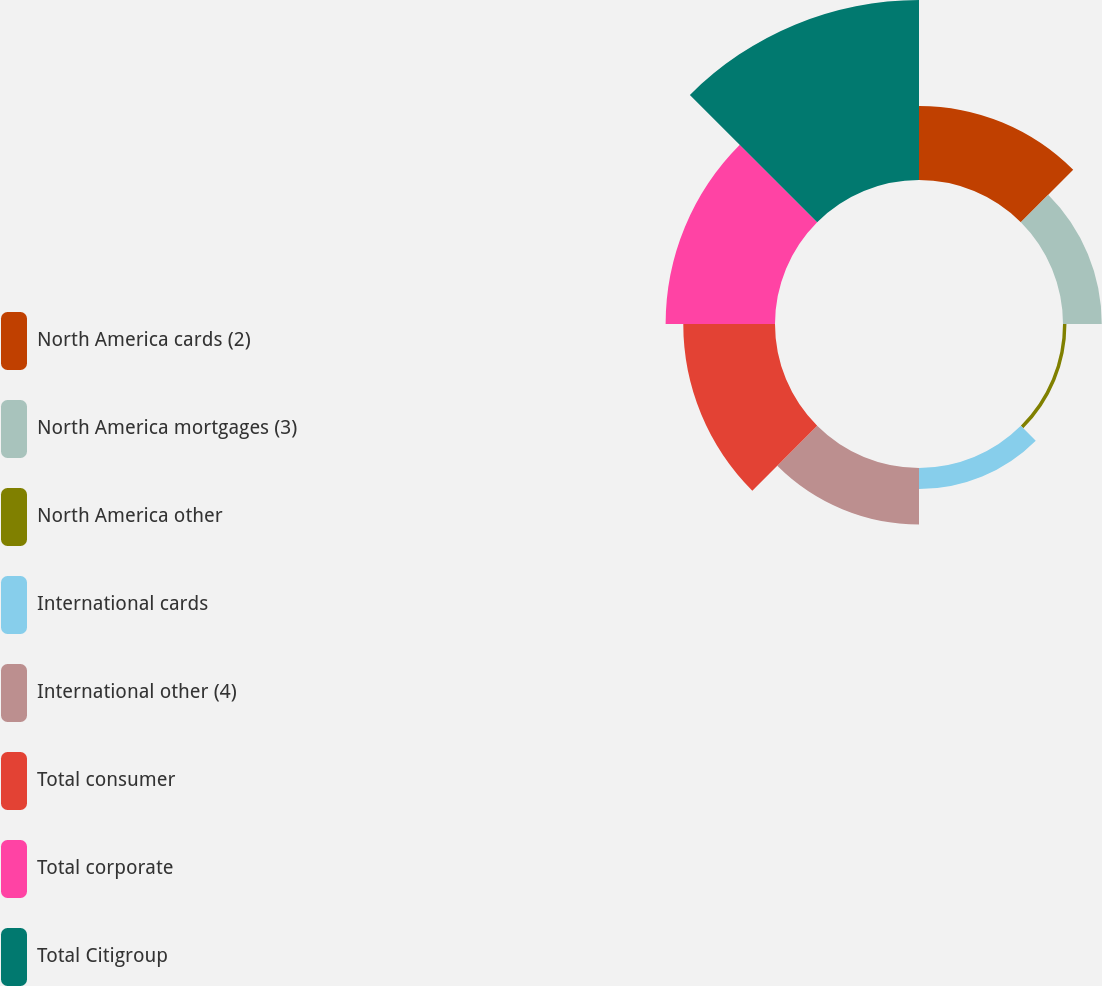<chart> <loc_0><loc_0><loc_500><loc_500><pie_chart><fcel>North America cards (2)<fcel>North America mortgages (3)<fcel>North America other<fcel>International cards<fcel>International other (4)<fcel>Total consumer<fcel>Total corporate<fcel>Total Citigroup<nl><fcel>12.88%<fcel>6.74%<fcel>0.6%<fcel>3.67%<fcel>9.81%<fcel>15.95%<fcel>19.02%<fcel>31.3%<nl></chart> 